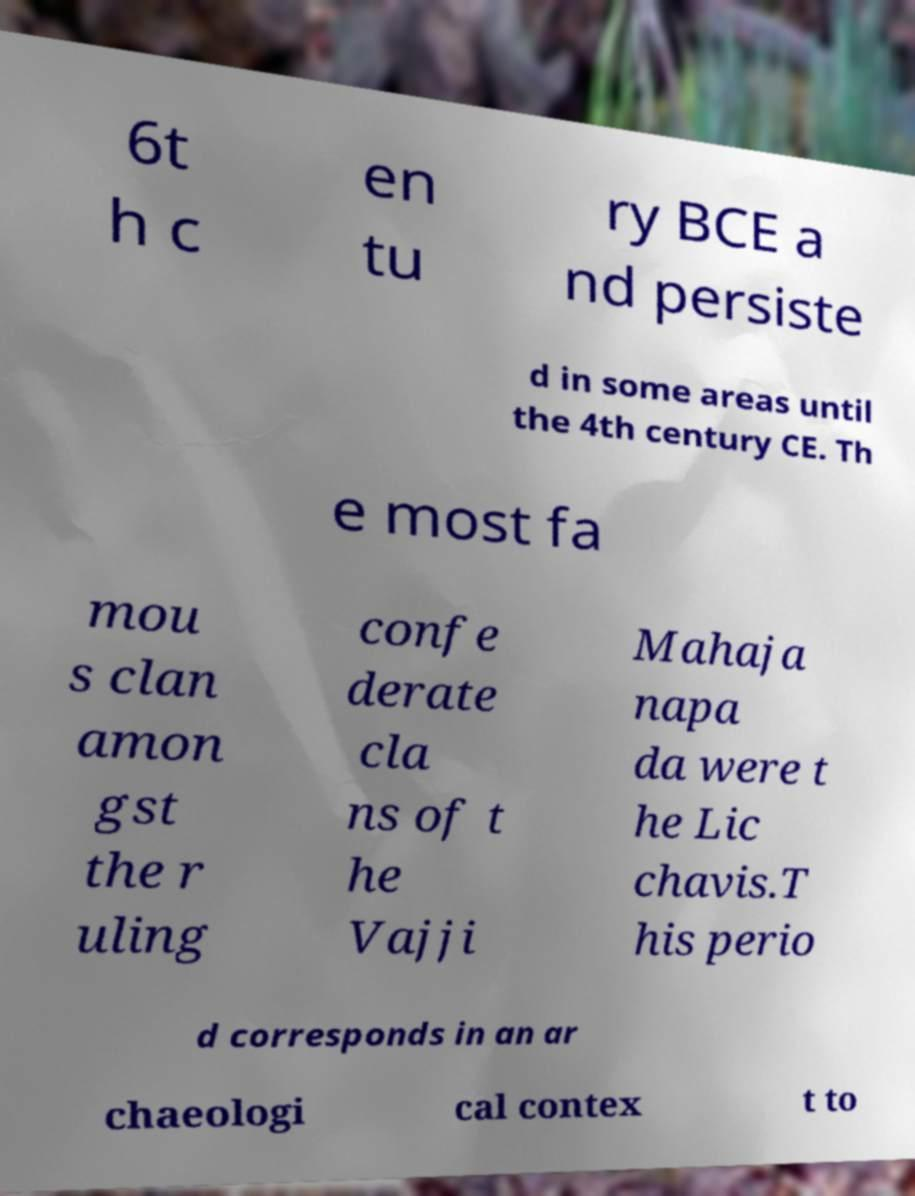Can you accurately transcribe the text from the provided image for me? 6t h c en tu ry BCE a nd persiste d in some areas until the 4th century CE. Th e most fa mou s clan amon gst the r uling confe derate cla ns of t he Vajji Mahaja napa da were t he Lic chavis.T his perio d corresponds in an ar chaeologi cal contex t to 